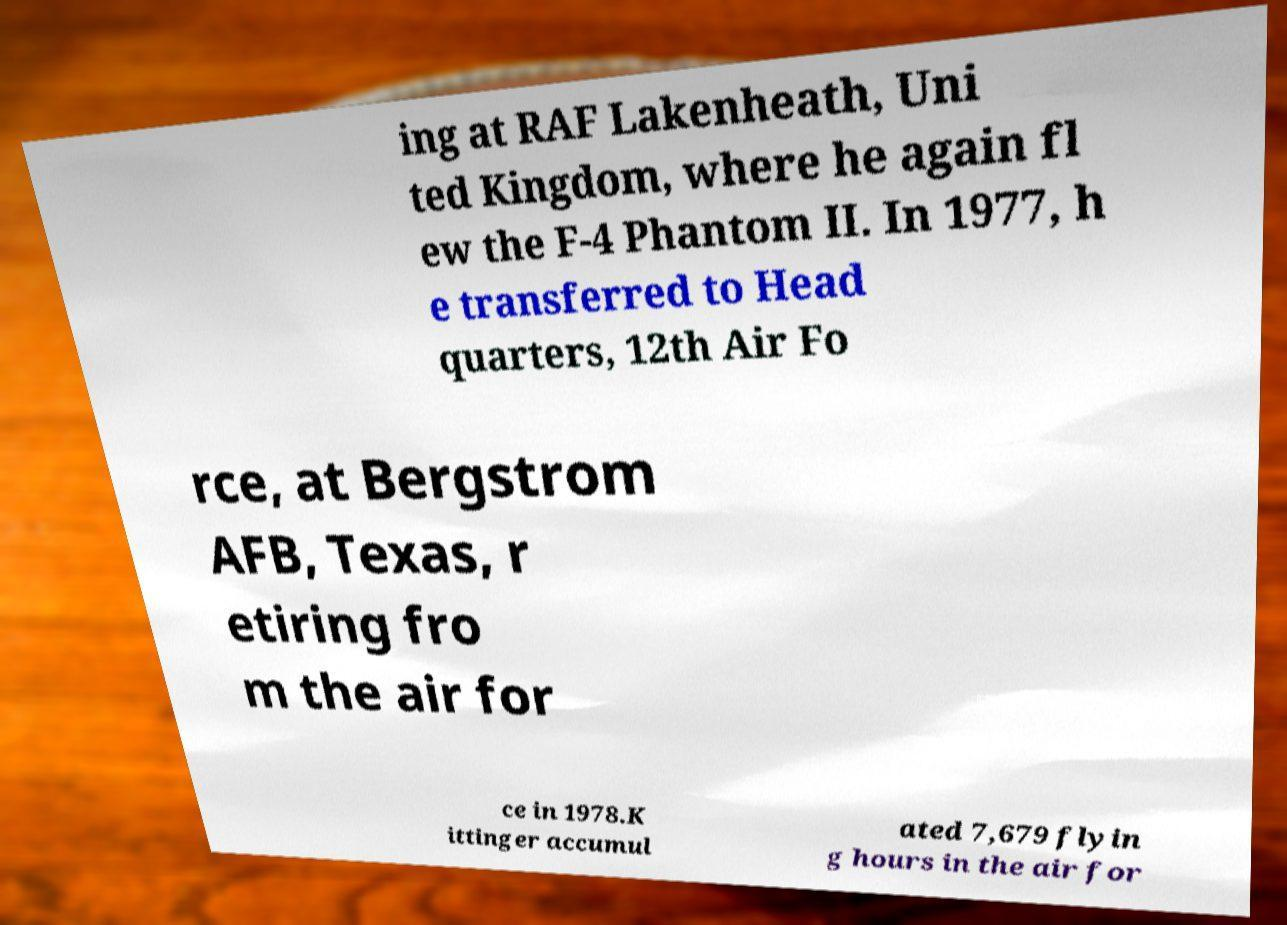I need the written content from this picture converted into text. Can you do that? ing at RAF Lakenheath, Uni ted Kingdom, where he again fl ew the F-4 Phantom II. In 1977, h e transferred to Head quarters, 12th Air Fo rce, at Bergstrom AFB, Texas, r etiring fro m the air for ce in 1978.K ittinger accumul ated 7,679 flyin g hours in the air for 